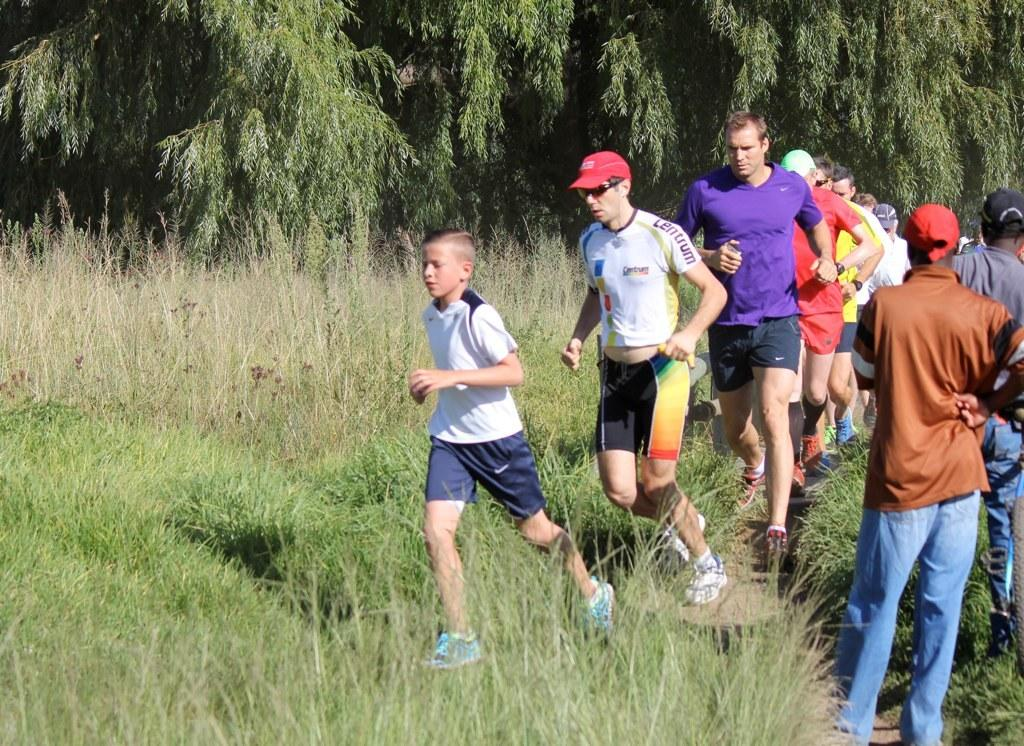What are the people in the foreground of the picture doing? The people in the foreground of the picture are running. What else can be seen in the foreground of the picture besides the people running? There are plants, grass, and a path visible in the foreground of the picture. What is the condition of the ground in the foreground of the picture? The ground in the foreground of the picture is covered with grass. What can be seen in the background of the picture? There are trees in the background of the picture. Where is the shelf located in the picture? There is no shelf present in the picture. What direction is the wind blowing in the picture? There is no indication of wind in the picture. 